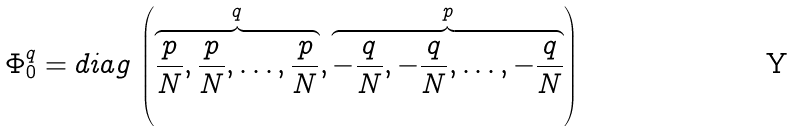<formula> <loc_0><loc_0><loc_500><loc_500>\Phi ^ { q } _ { 0 } = d i a g \, \left ( \overbrace { \frac { p } { N } , \frac { p } { N } , \dots , \frac { p } { N } } ^ { q } , \overbrace { - \frac { q } { N } , - \frac { q } { N } , \dots , - \frac { q } { N } } ^ { p } \right )</formula> 